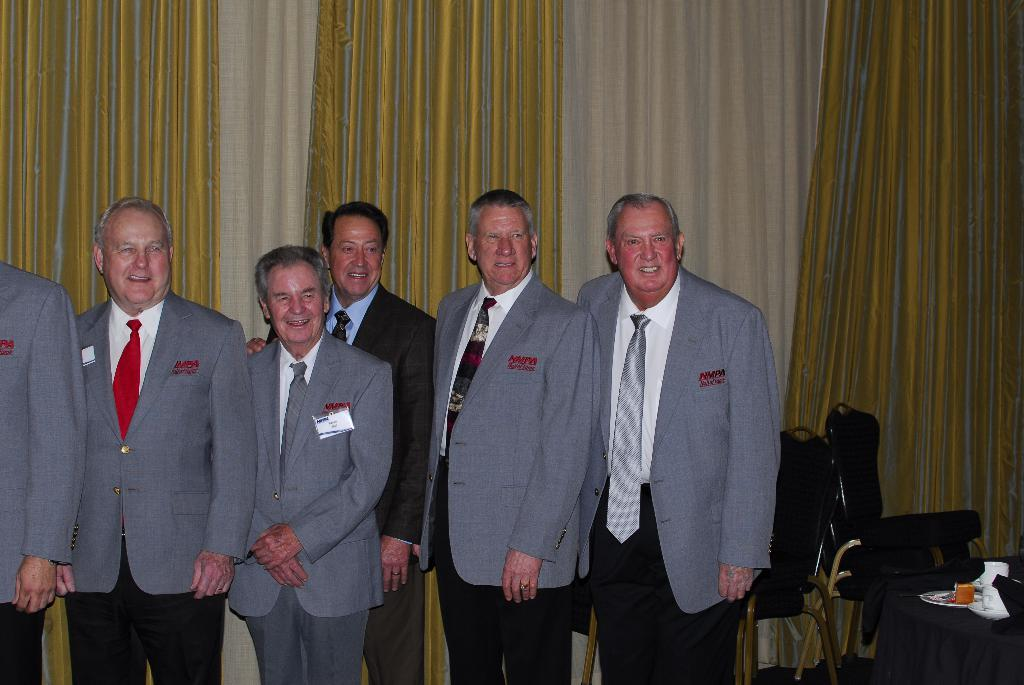What can be seen in the image involving people? There are people standing in the image. What type of furniture is present in the image? There are chairs in the image. What is covering the table in the image? There is a table covered with cloth in the image. What is on top of the table in the image? There are objects on the table in the image. What can be seen in the background of the image? There are curtains in the background of the image. What type of beef is being prepared on the apparatus in the image? There is no beef or apparatus present in the image. What subject is being taught in the school setting in the image? There is no school setting or subject being taught in the image. 